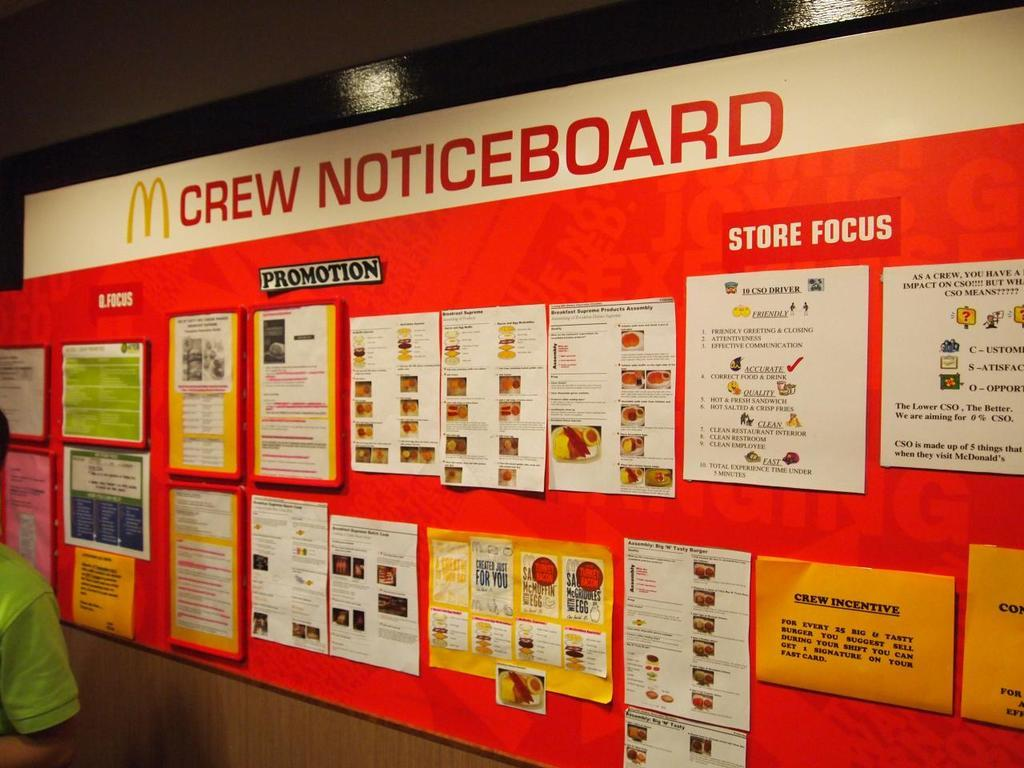<image>
Create a compact narrative representing the image presented. A McDonald's crew noticeboard with sections for store focus and promotions 